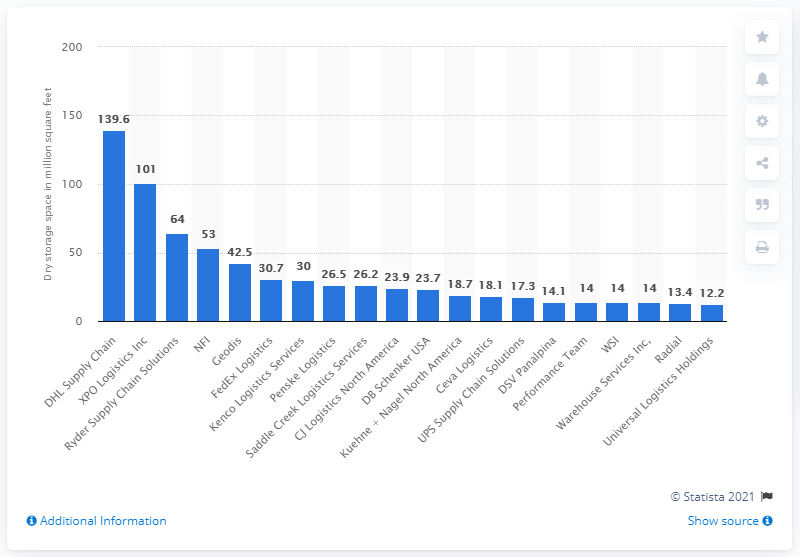Highlight a few significant elements in this photo. In 2020, the storage capacity of DHL in the U.S. and Canada was 139.6. 